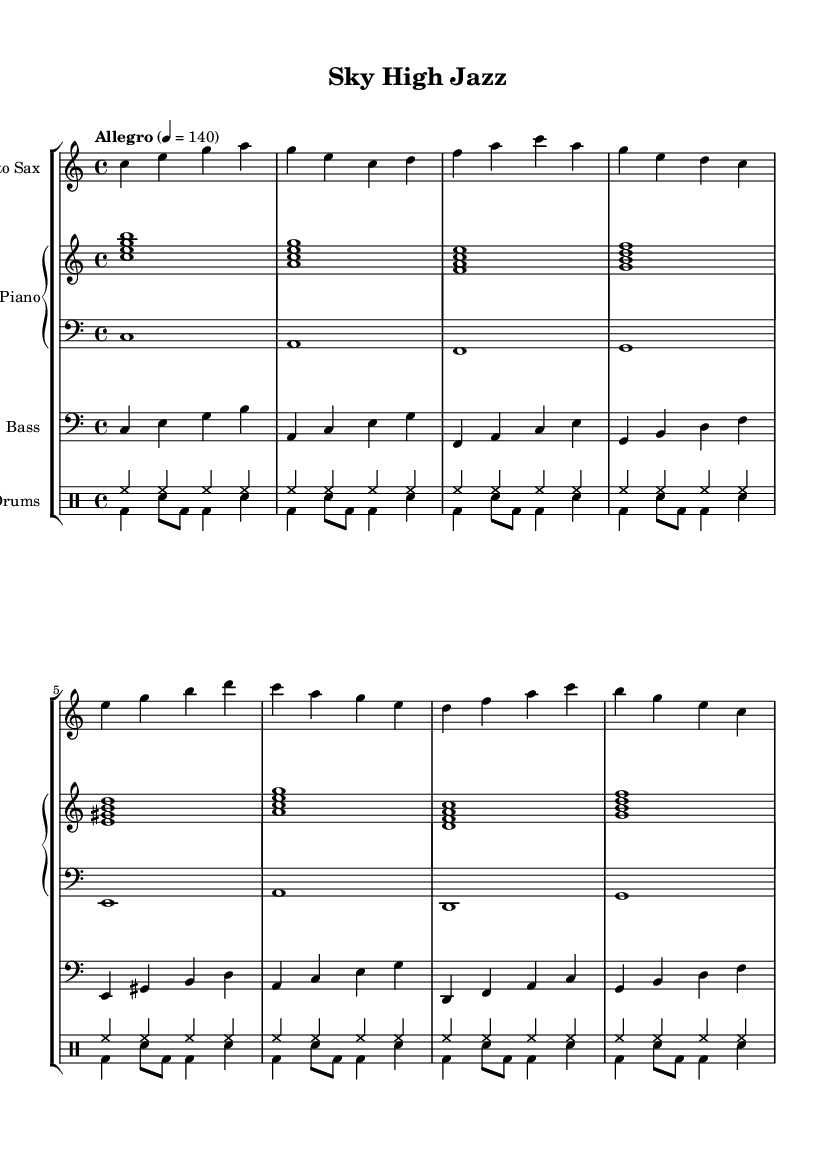What is the key signature of this music? The key signature is indicated by the lack of sharps or flats at the beginning of the staff, which signifies that the piece is in C major.
Answer: C major What is the time signature of this music? The time signature is located at the beginning of the staff, indicated by the 4 over 4, meaning there are four beats in a measure and the quarter note gets the beat.
Answer: 4/4 What is the tempo marking for this piece? The tempo marking is located at the beginning of the score, indicating "Allegro" with a metronome marking of quarter note equals 140, which denotes a fast pace.
Answer: 140 How many measures does the saxophone part contain? Counting the measures in the saxophone part, there are a total of 8 measures. Each grouping is separated by a vertical line.
Answer: 8 What is the primary instrument featured in this piece? The piece prominently features saxophone as indicated by its placement in the staff group, which is labeled as "Alto Sax." It is specifically noted in the header of the staff.
Answer: Alto Sax What kind of drum pattern is used in this piece? The drum part displays a combination of unpitched and pitched notes, characterized by the use of bass drums and snare hits, creating a swing feel typical in jazz.
Answer: Swing feel Is there any chord voicing shown in the piano part? The piano right-hand part features chord voicings combined in multiple notes played together, showing harmonization, while the left-hand part plays single root notes to complement them.
Answer: Yes 